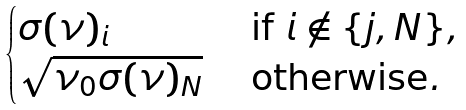Convert formula to latex. <formula><loc_0><loc_0><loc_500><loc_500>\begin{cases} \sigma ( \nu ) _ { i } & \text { if } i \not \in \{ j , N \} , \\ \sqrt { \nu _ { 0 } \sigma ( \nu ) _ { N } } & \text { otherwise} . \end{cases}</formula> 